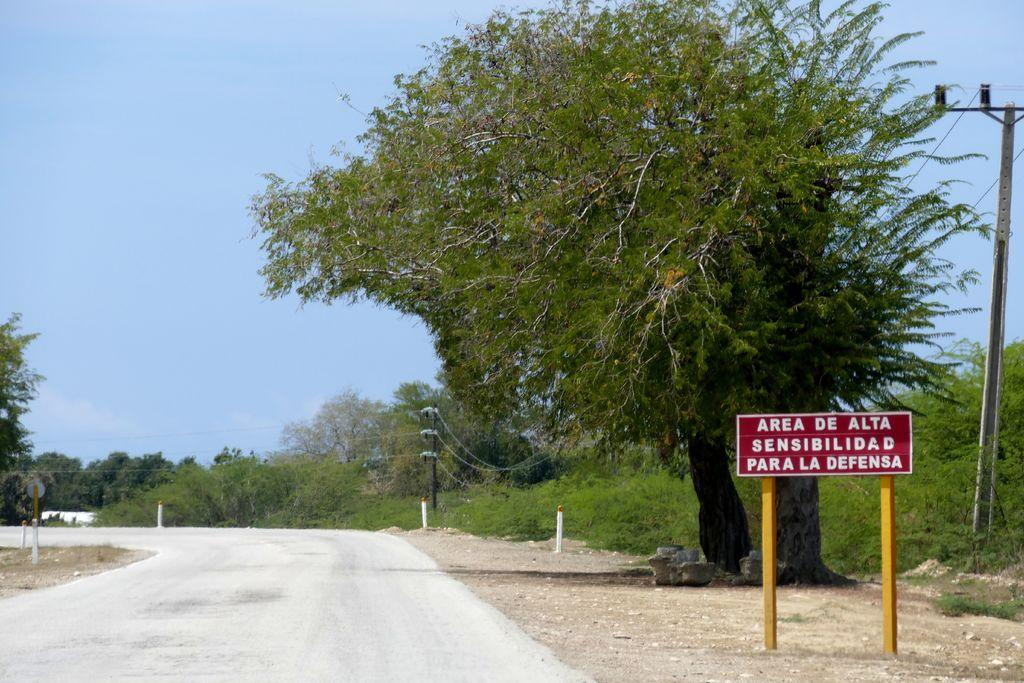What type of natural elements can be seen in the image? There are trees in the image. What man-made structures are present in the image? There are electrical poles and a road in the image. What type of signage is visible in the image? There is a board with text in the image. What is the color of the sky in the image? The sky is blue in the image. How many cats can be seen on the roof in the image? There are no cats or roof present in the image. What type of fang is visible on the electrical poles in the image? There are no fangs present in the image; the electrical poles are standard utility poles. 